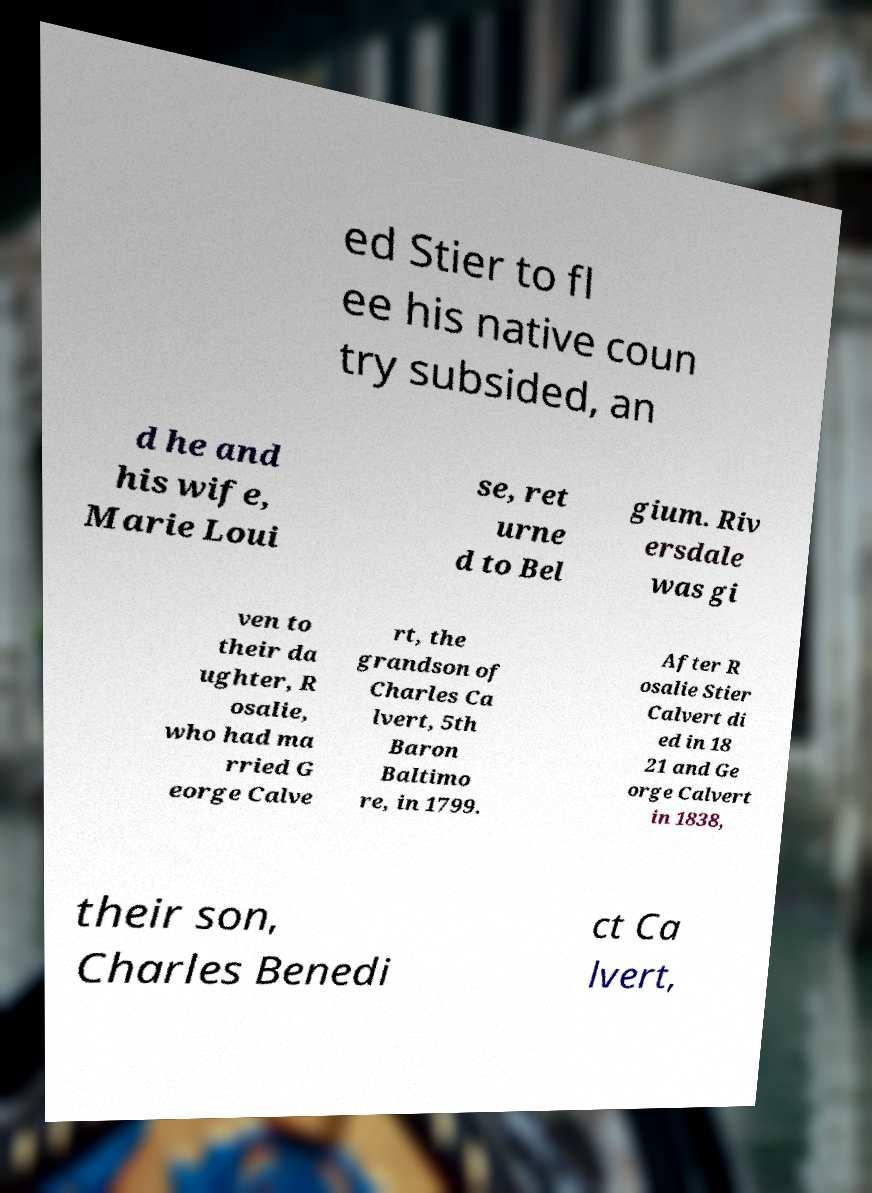Could you extract and type out the text from this image? ed Stier to fl ee his native coun try subsided, an d he and his wife, Marie Loui se, ret urne d to Bel gium. Riv ersdale was gi ven to their da ughter, R osalie, who had ma rried G eorge Calve rt, the grandson of Charles Ca lvert, 5th Baron Baltimo re, in 1799. After R osalie Stier Calvert di ed in 18 21 and Ge orge Calvert in 1838, their son, Charles Benedi ct Ca lvert, 